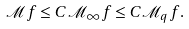<formula> <loc_0><loc_0><loc_500><loc_500>\mathcal { M } f \leq C \mathcal { M } _ { \infty } f \leq C \mathcal { M } _ { q } f .</formula> 